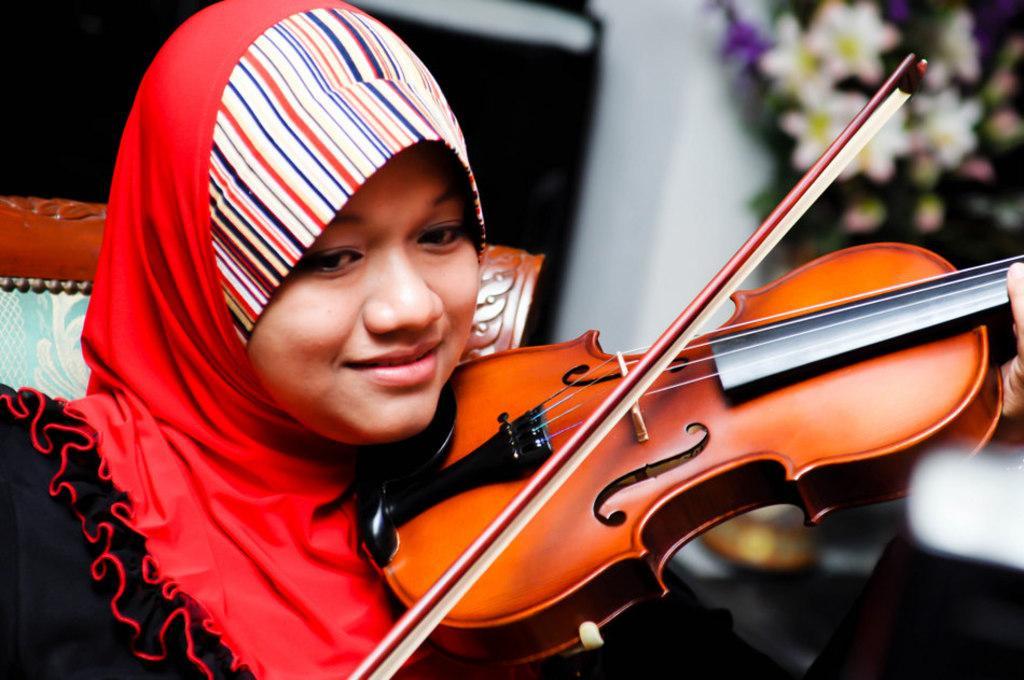Please provide a concise description of this image. This person sitting on the chair and holding violin. 